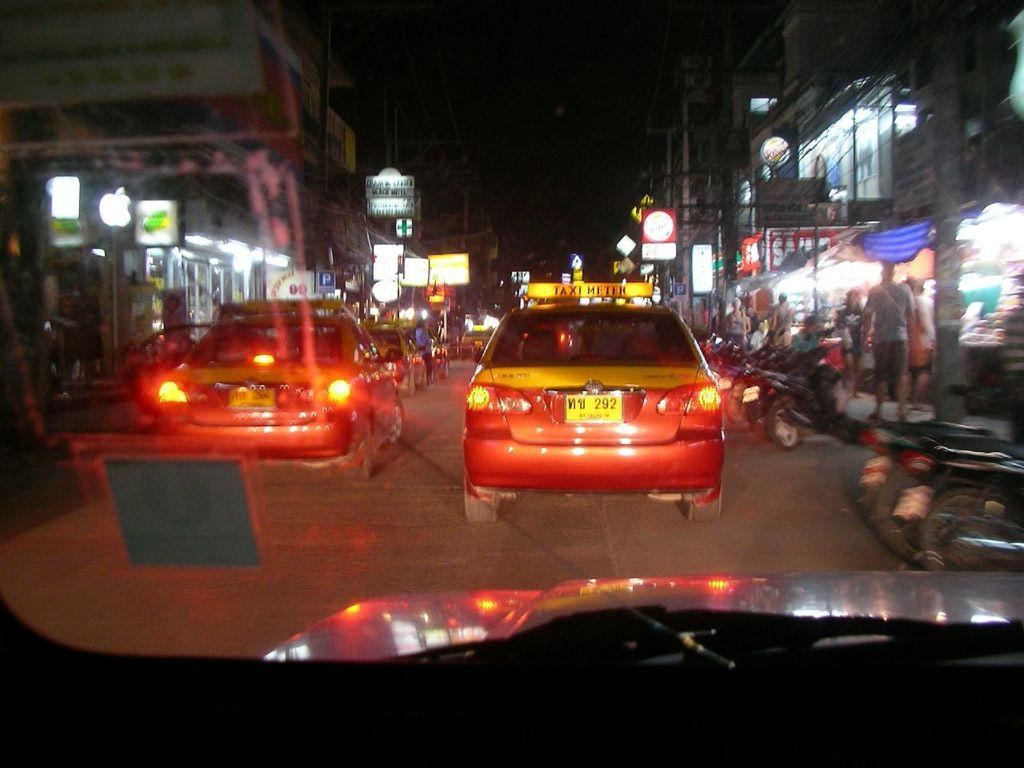<image>
Create a compact narrative representing the image presented. A red and yellow Taxi's license plate has the number 292 in it. 